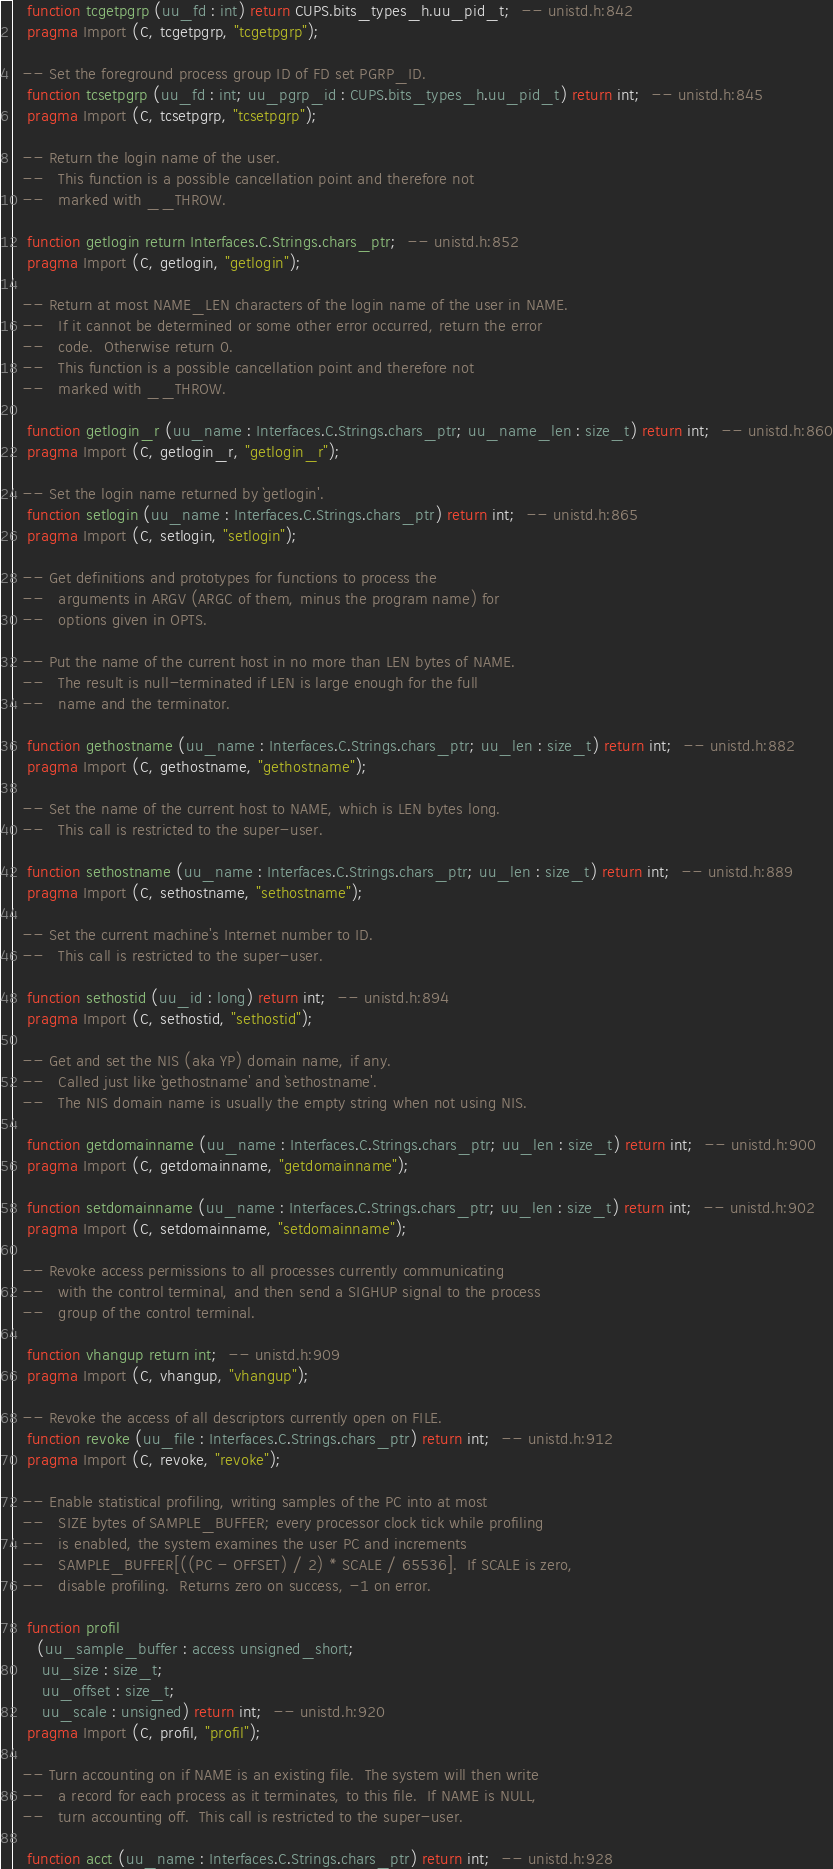<code> <loc_0><loc_0><loc_500><loc_500><_Ada_>   function tcgetpgrp (uu_fd : int) return CUPS.bits_types_h.uu_pid_t;  -- unistd.h:842
   pragma Import (C, tcgetpgrp, "tcgetpgrp");

  -- Set the foreground process group ID of FD set PGRP_ID.   
   function tcsetpgrp (uu_fd : int; uu_pgrp_id : CUPS.bits_types_h.uu_pid_t) return int;  -- unistd.h:845
   pragma Import (C, tcsetpgrp, "tcsetpgrp");

  -- Return the login name of the user.
  --   This function is a possible cancellation point and therefore not
  --   marked with __THROW.   

   function getlogin return Interfaces.C.Strings.chars_ptr;  -- unistd.h:852
   pragma Import (C, getlogin, "getlogin");

  -- Return at most NAME_LEN characters of the login name of the user in NAME.
  --   If it cannot be determined or some other error occurred, return the error
  --   code.  Otherwise return 0.
  --   This function is a possible cancellation point and therefore not
  --   marked with __THROW.   

   function getlogin_r (uu_name : Interfaces.C.Strings.chars_ptr; uu_name_len : size_t) return int;  -- unistd.h:860
   pragma Import (C, getlogin_r, "getlogin_r");

  -- Set the login name returned by `getlogin'.   
   function setlogin (uu_name : Interfaces.C.Strings.chars_ptr) return int;  -- unistd.h:865
   pragma Import (C, setlogin, "setlogin");

  -- Get definitions and prototypes for functions to process the
  --   arguments in ARGV (ARGC of them, minus the program name) for
  --   options given in OPTS.   

  -- Put the name of the current host in no more than LEN bytes of NAME.
  --   The result is null-terminated if LEN is large enough for the full
  --   name and the terminator.   

   function gethostname (uu_name : Interfaces.C.Strings.chars_ptr; uu_len : size_t) return int;  -- unistd.h:882
   pragma Import (C, gethostname, "gethostname");

  -- Set the name of the current host to NAME, which is LEN bytes long.
  --   This call is restricted to the super-user.   

   function sethostname (uu_name : Interfaces.C.Strings.chars_ptr; uu_len : size_t) return int;  -- unistd.h:889
   pragma Import (C, sethostname, "sethostname");

  -- Set the current machine's Internet number to ID.
  --   This call is restricted to the super-user.   

   function sethostid (uu_id : long) return int;  -- unistd.h:894
   pragma Import (C, sethostid, "sethostid");

  -- Get and set the NIS (aka YP) domain name, if any.
  --   Called just like `gethostname' and `sethostname'.
  --   The NIS domain name is usually the empty string when not using NIS.   

   function getdomainname (uu_name : Interfaces.C.Strings.chars_ptr; uu_len : size_t) return int;  -- unistd.h:900
   pragma Import (C, getdomainname, "getdomainname");

   function setdomainname (uu_name : Interfaces.C.Strings.chars_ptr; uu_len : size_t) return int;  -- unistd.h:902
   pragma Import (C, setdomainname, "setdomainname");

  -- Revoke access permissions to all processes currently communicating
  --   with the control terminal, and then send a SIGHUP signal to the process
  --   group of the control terminal.   

   function vhangup return int;  -- unistd.h:909
   pragma Import (C, vhangup, "vhangup");

  -- Revoke the access of all descriptors currently open on FILE.   
   function revoke (uu_file : Interfaces.C.Strings.chars_ptr) return int;  -- unistd.h:912
   pragma Import (C, revoke, "revoke");

  -- Enable statistical profiling, writing samples of the PC into at most
  --   SIZE bytes of SAMPLE_BUFFER; every processor clock tick while profiling
  --   is enabled, the system examines the user PC and increments
  --   SAMPLE_BUFFER[((PC - OFFSET) / 2) * SCALE / 65536].  If SCALE is zero,
  --   disable profiling.  Returns zero on success, -1 on error.   

   function profil
     (uu_sample_buffer : access unsigned_short;
      uu_size : size_t;
      uu_offset : size_t;
      uu_scale : unsigned) return int;  -- unistd.h:920
   pragma Import (C, profil, "profil");

  -- Turn accounting on if NAME is an existing file.  The system will then write
  --   a record for each process as it terminates, to this file.  If NAME is NULL,
  --   turn accounting off.  This call is restricted to the super-user.   

   function acct (uu_name : Interfaces.C.Strings.chars_ptr) return int;  -- unistd.h:928</code> 